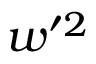<formula> <loc_0><loc_0><loc_500><loc_500>w ^ { \prime 2 }</formula> 